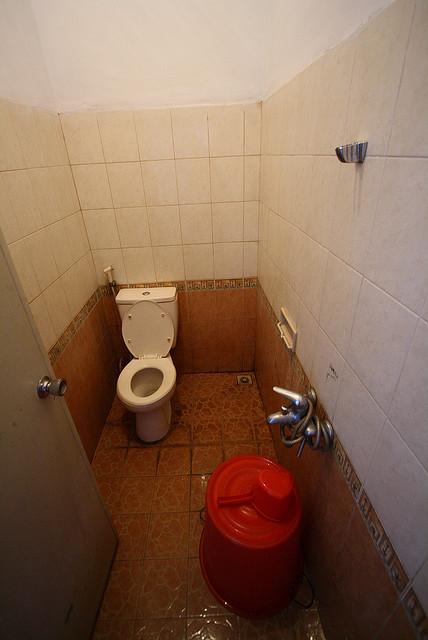Is the toilet lid up?
Be succinct. Yes. Who cleaned this room?
Answer briefly. Janitor. Why might the floor be wet?
Concise answer only. Leak. 